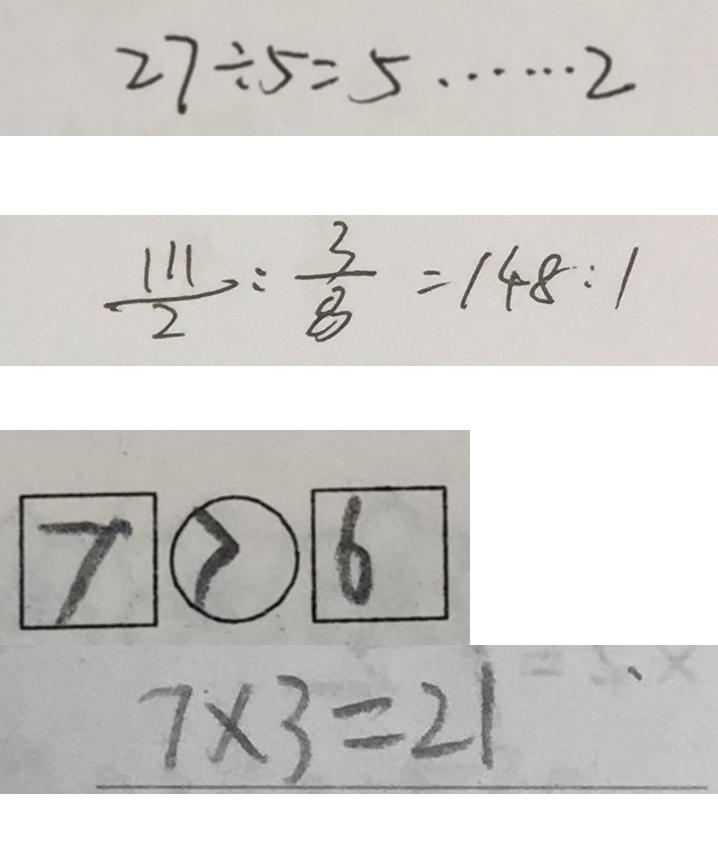Convert formula to latex. <formula><loc_0><loc_0><loc_500><loc_500>2 7 \div 5 = 5 \cdots 2 
 \frac { 1 1 1 } { 2 } : \frac { 3 } { 8 } = 1 4 8 : 1 
 \boxed { 7 } \textcircled { > } \boxed { 6 } 
 7 \times 3 = 2 1</formula> 